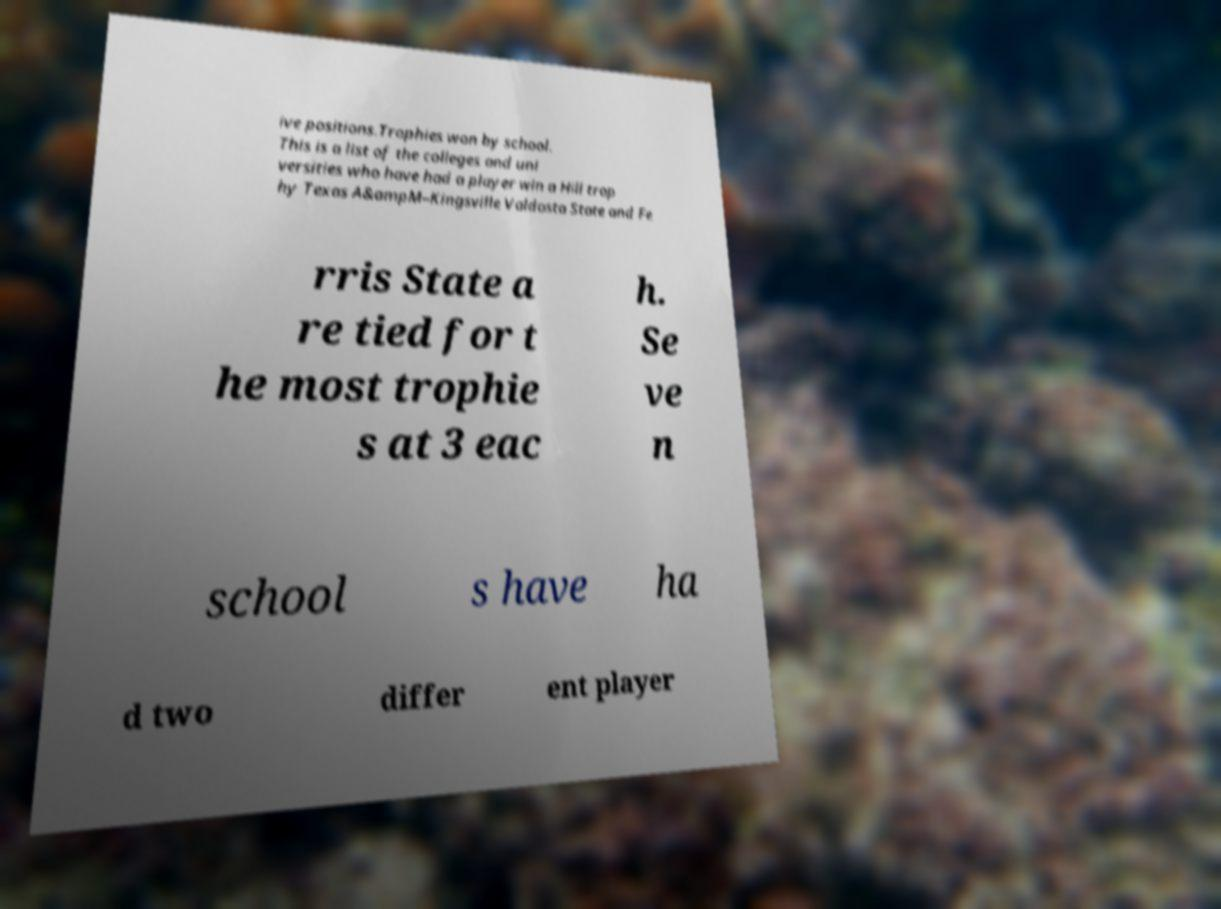Please identify and transcribe the text found in this image. ive positions.Trophies won by school. This is a list of the colleges and uni versities who have had a player win a Hill trop hy Texas A&ampM–Kingsville Valdosta State and Fe rris State a re tied for t he most trophie s at 3 eac h. Se ve n school s have ha d two differ ent player 